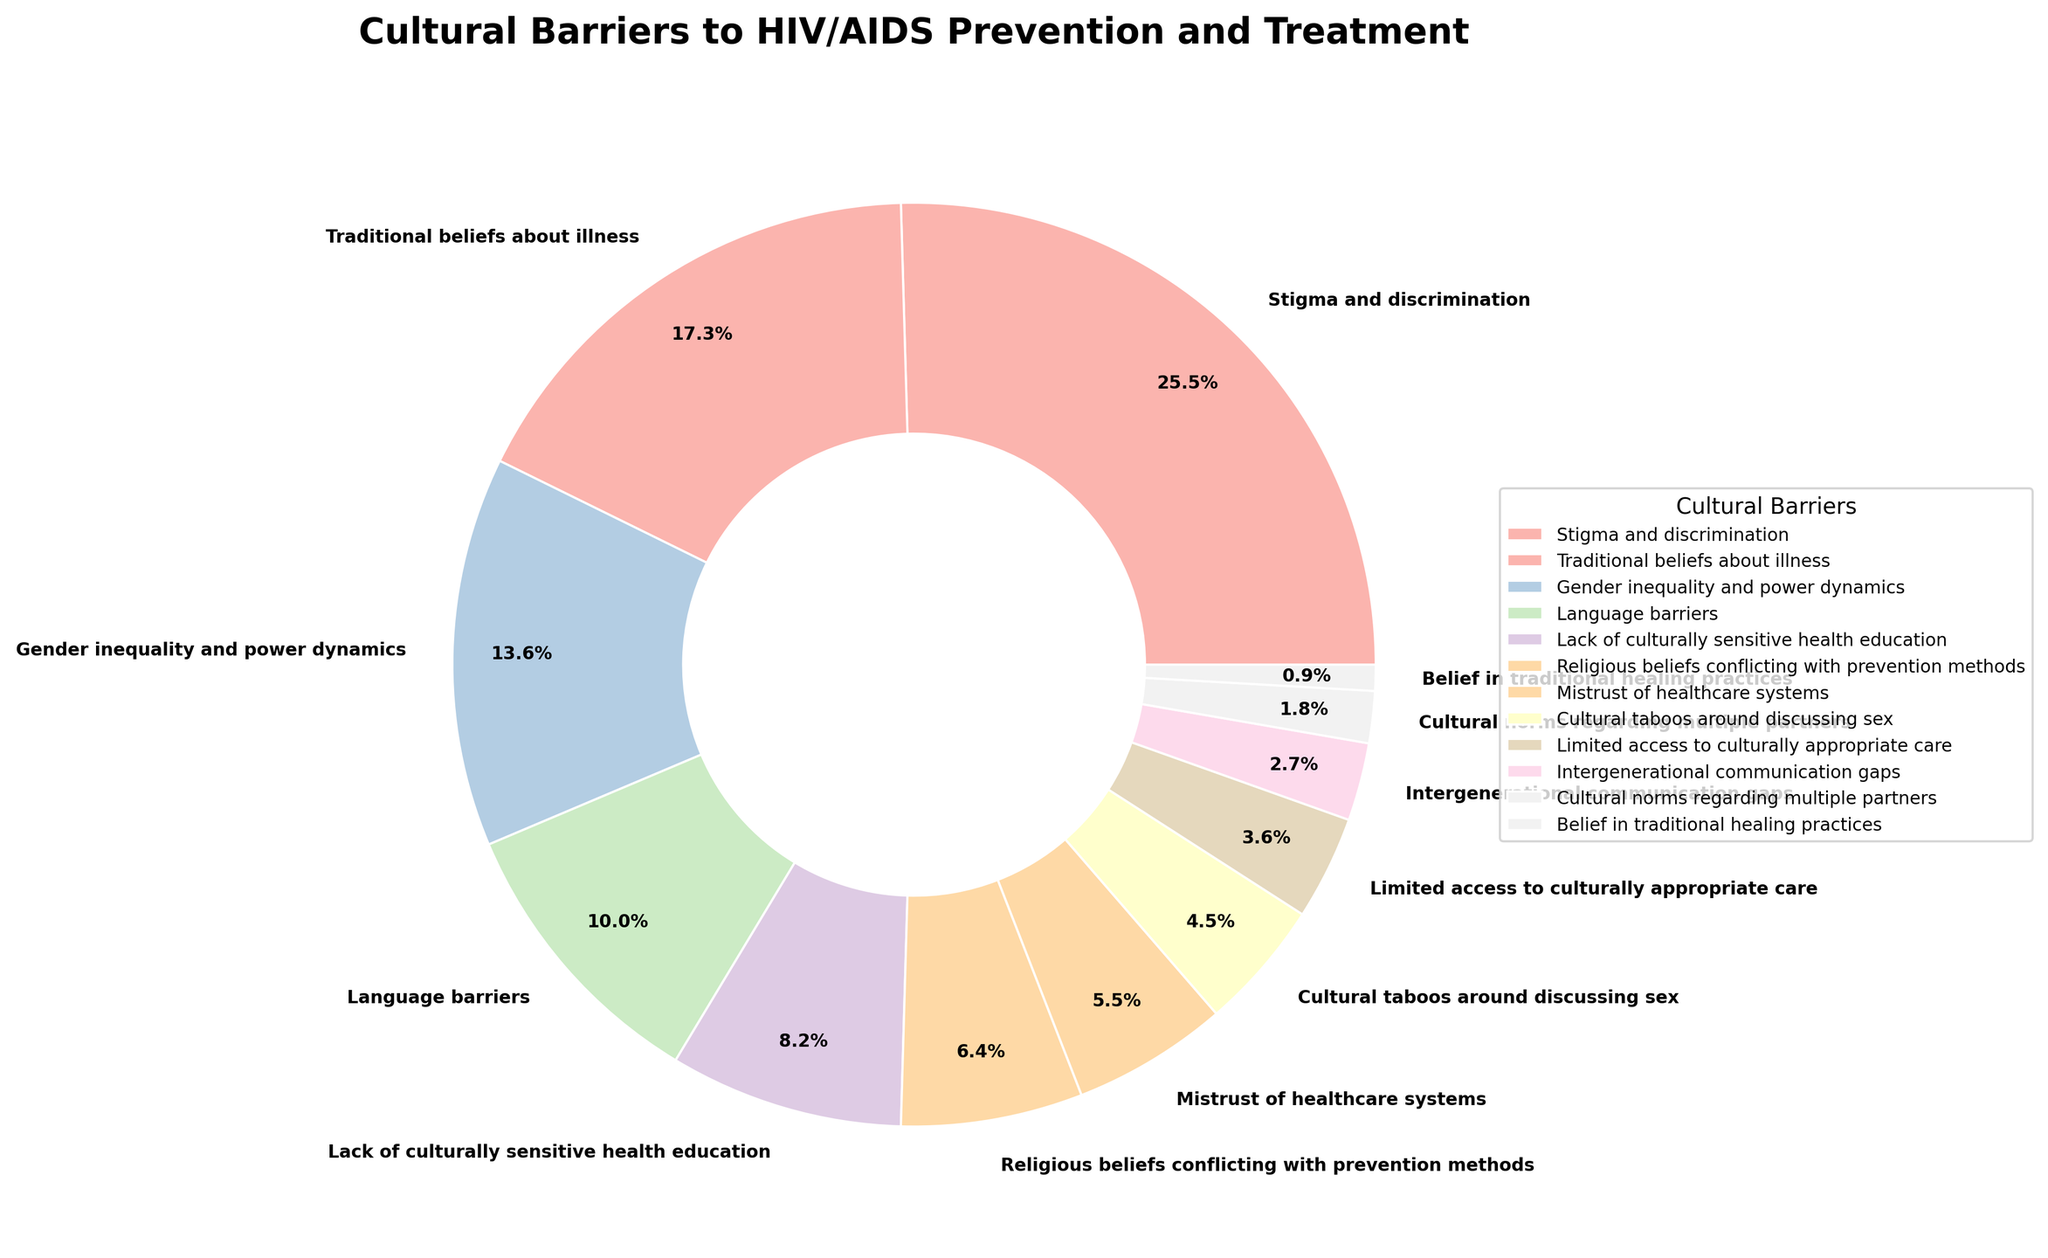What's the largest cultural barrier to HIV/AIDS prevention and treatment in the target population? Look at the pie chart and identify the section with the highest percentage. The section labeled "Stigma and discrimination" has the highest percentage at 28%.
Answer: Stigma and discrimination What is the cumulative percentage of the three least prevalent cultural barriers? Identify the three smallest segments and sum their percentages. The smallest segments are "Belief in traditional healing practices" (1%), "Cultural norms regarding multiple partners" (2%), and "Intergenerational communication gaps" (3%). Sum them: 1% + 2% + 3% = 6%.
Answer: 6% Which cultural barrier has a higher percentage: Gender inequality and power dynamics or Language barriers? Compare the percentages of these two segments. "Gender inequality and power dynamics" has 15%, and "Language barriers" has 11%. Thus, "Gender inequality and power dynamics" is higher.
Answer: Gender inequality and power dynamics What is the total percentage for cultural barriers related to beliefs (both traditional and religious)? Add the percentages of "Traditional beliefs about illness" and "Religious beliefs conflicting with prevention methods". "Traditional beliefs about illness" is 19% and "Religious beliefs conflicting with prevention methods" is 7%. Sum them: 19% + 7% = 26%.
Answer: 26% How much more significant is the barrier of "Stigma and discrimination" compared to "Mistrust of healthcare systems"? Subtract the percentage of "Mistrust of healthcare systems" from "Stigma and discrimination". "Stigma and discrimination" is 28%, and "Mistrust of healthcare systems" is 6%. Difference: 28% - 6% = 22%.
Answer: 22% What proportion of the target population is affected by both "Gender inequality and power dynamics" and "Lack of culturally sensitive health education"? Add the percentages of these two segments. "Gender inequality and power dynamics" is 15%, and "Lack of culturally sensitive health education" is 9%. Sum them: 15% + 9% = 24%.
Answer: 24% Among "Language barriers" and "Cultural taboos around discussing sex," which is the lesser barrier and by how much? Compare the percentages of "Language barriers" and "Cultural taboos around discussing sex". "Language barriers" is 11%, and "Cultural taboos around discussing sex" is 5%. Calculate the difference: 11% - 5% = 6%.
Answer: Cultural taboos around discussing sex by 6% How much does "Traditional beliefs about illness" contribute to the overall barriers compared to "Limited access to culturally appropriate care"? Compare the percentages of "Traditional beliefs about illness" and "Limited access to culturally appropriate care". "Traditional beliefs about illness" is 19%, and "Limited access to culturally appropriate care" is 4%. Difference: 19% - 4% = 15%.
Answer: 15% What is the combined percentage of barriers related to communication: "Language barriers" and "Intergenerational communication gaps"? Add the percentages of these two segments. "Language barriers" is 11%, and "Intergenerational communication gaps" is 3%. Sum them: 11% + 3% = 14%.
Answer: 14% Which cultural barrier related to partners contributes 2%? Find the segment labeled with 2%. It is "Cultural norms regarding multiple partners."
Answer: Cultural norms regarding multiple partners 